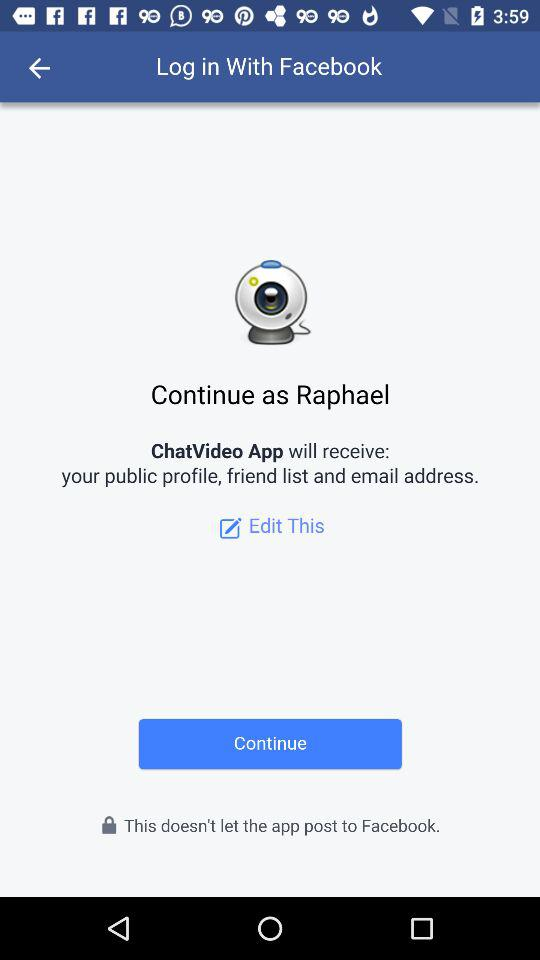What is the name of the user? The name of the user is Raphael. 